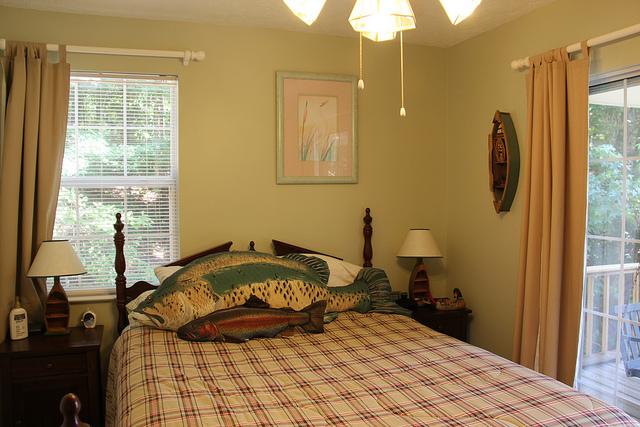Are the lights on?
Give a very brief answer. Yes. How many fish are on the bed?
Short answer required. 2. Are those fish pillows?
Write a very short answer. Yes. 